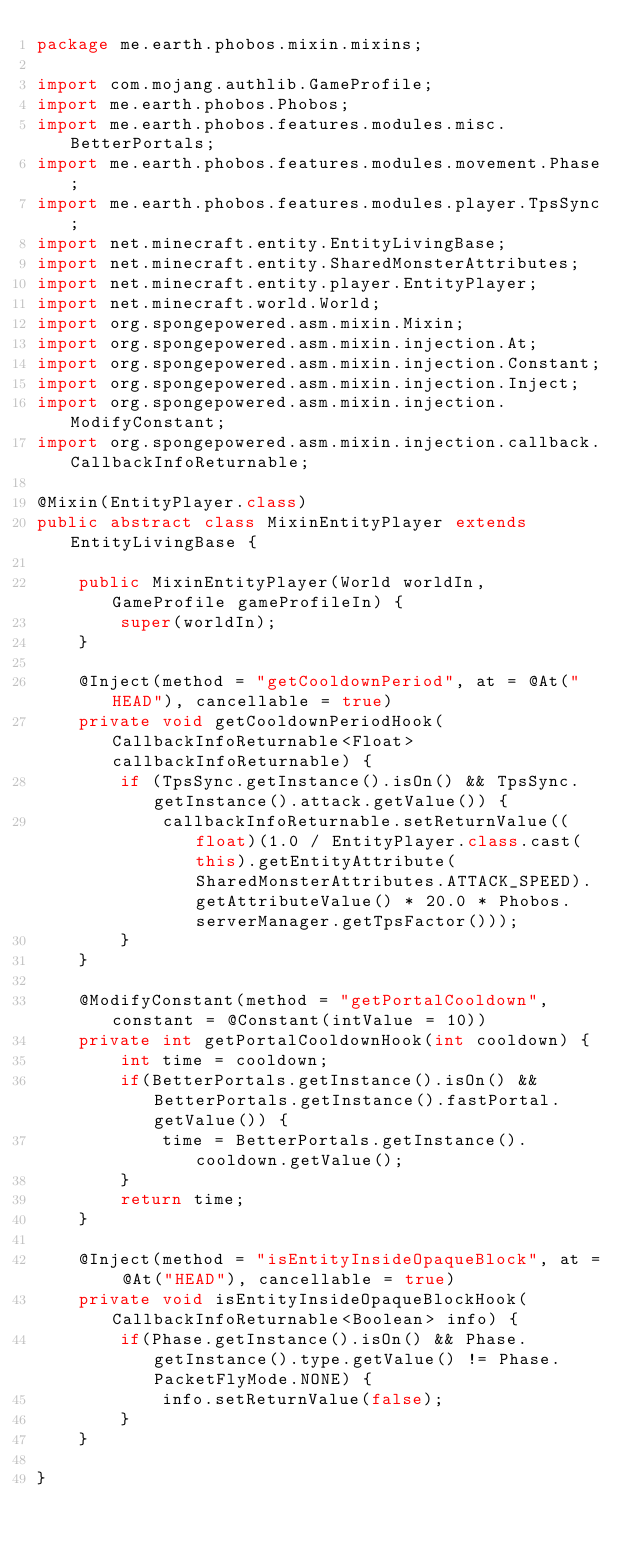Convert code to text. <code><loc_0><loc_0><loc_500><loc_500><_Java_>package me.earth.phobos.mixin.mixins;

import com.mojang.authlib.GameProfile;
import me.earth.phobos.Phobos;
import me.earth.phobos.features.modules.misc.BetterPortals;
import me.earth.phobos.features.modules.movement.Phase;
import me.earth.phobos.features.modules.player.TpsSync;
import net.minecraft.entity.EntityLivingBase;
import net.minecraft.entity.SharedMonsterAttributes;
import net.minecraft.entity.player.EntityPlayer;
import net.minecraft.world.World;
import org.spongepowered.asm.mixin.Mixin;
import org.spongepowered.asm.mixin.injection.At;
import org.spongepowered.asm.mixin.injection.Constant;
import org.spongepowered.asm.mixin.injection.Inject;
import org.spongepowered.asm.mixin.injection.ModifyConstant;
import org.spongepowered.asm.mixin.injection.callback.CallbackInfoReturnable;

@Mixin(EntityPlayer.class)
public abstract class MixinEntityPlayer extends EntityLivingBase {

    public MixinEntityPlayer(World worldIn, GameProfile gameProfileIn) {
        super(worldIn);
    }

    @Inject(method = "getCooldownPeriod", at = @At("HEAD"), cancellable = true)
    private void getCooldownPeriodHook(CallbackInfoReturnable<Float> callbackInfoReturnable) {
        if (TpsSync.getInstance().isOn() && TpsSync.getInstance().attack.getValue()) {
            callbackInfoReturnable.setReturnValue((float)(1.0 / EntityPlayer.class.cast(this).getEntityAttribute(SharedMonsterAttributes.ATTACK_SPEED).getAttributeValue() * 20.0 * Phobos.serverManager.getTpsFactor()));
        }
    }

    @ModifyConstant(method = "getPortalCooldown", constant = @Constant(intValue = 10))
    private int getPortalCooldownHook(int cooldown) {
        int time = cooldown;
        if(BetterPortals.getInstance().isOn() && BetterPortals.getInstance().fastPortal.getValue()) {
            time = BetterPortals.getInstance().cooldown.getValue();
        }
        return time;
    }

    @Inject(method = "isEntityInsideOpaqueBlock", at = @At("HEAD"), cancellable = true)
    private void isEntityInsideOpaqueBlockHook(CallbackInfoReturnable<Boolean> info) {
        if(Phase.getInstance().isOn() && Phase.getInstance().type.getValue() != Phase.PacketFlyMode.NONE) {
            info.setReturnValue(false);
        }
    }

}
</code> 